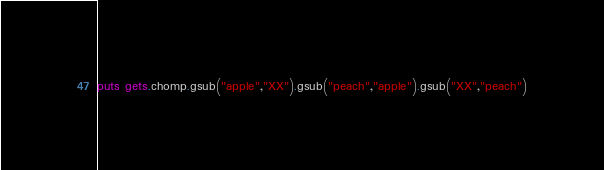Convert code to text. <code><loc_0><loc_0><loc_500><loc_500><_Ruby_>puts gets.chomp.gsub("apple","XX").gsub("peach","apple").gsub("XX","peach")</code> 